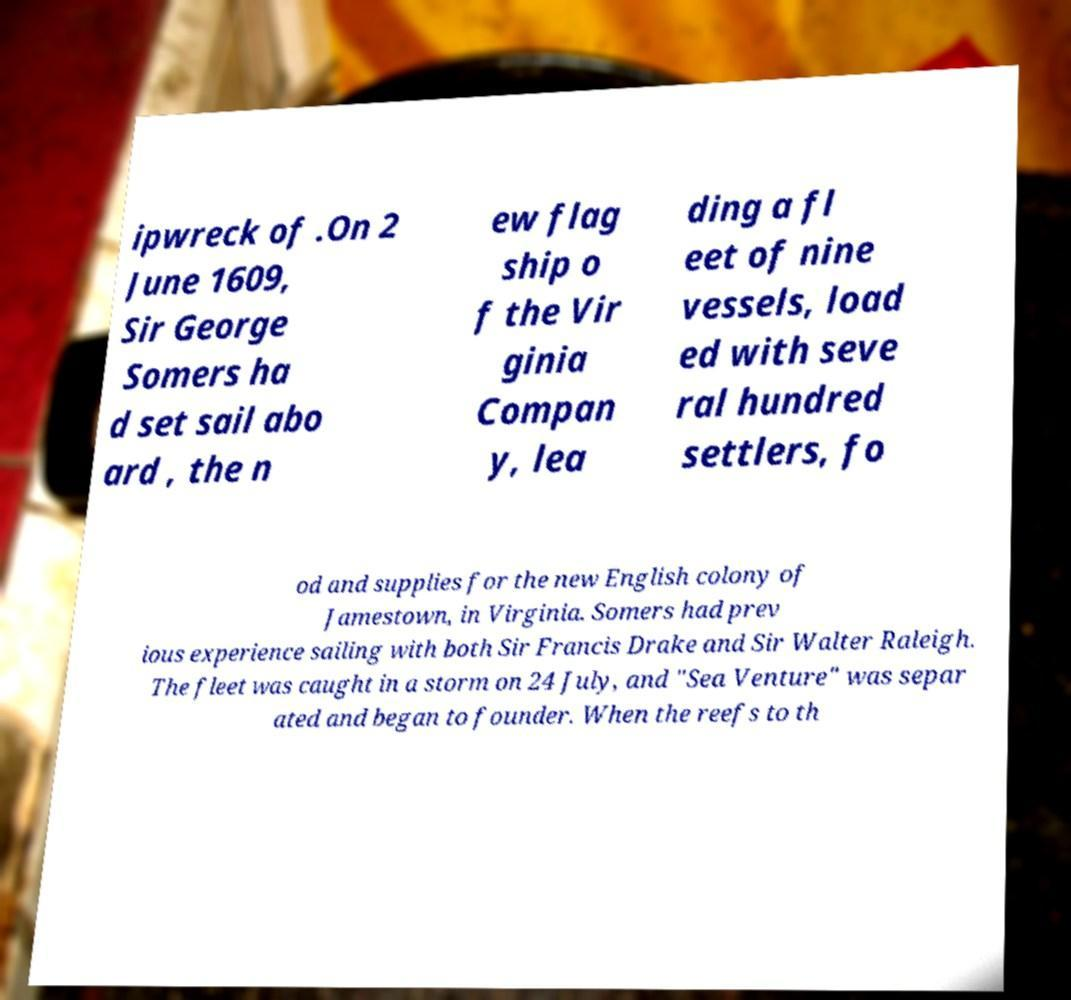I need the written content from this picture converted into text. Can you do that? ipwreck of .On 2 June 1609, Sir George Somers ha d set sail abo ard , the n ew flag ship o f the Vir ginia Compan y, lea ding a fl eet of nine vessels, load ed with seve ral hundred settlers, fo od and supplies for the new English colony of Jamestown, in Virginia. Somers had prev ious experience sailing with both Sir Francis Drake and Sir Walter Raleigh. The fleet was caught in a storm on 24 July, and "Sea Venture" was separ ated and began to founder. When the reefs to th 